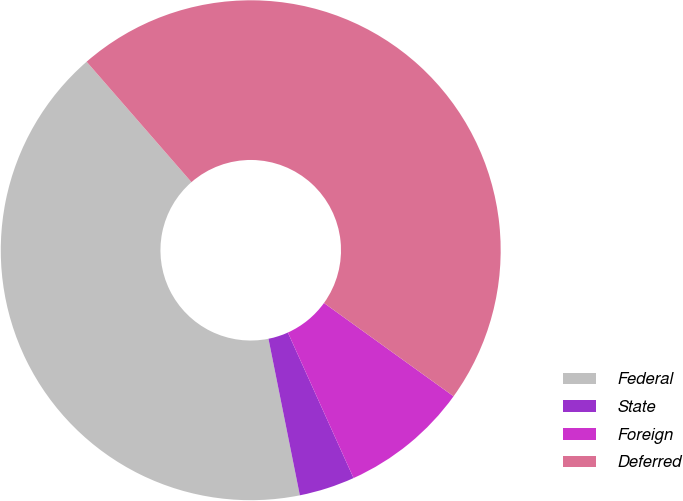<chart> <loc_0><loc_0><loc_500><loc_500><pie_chart><fcel>Federal<fcel>State<fcel>Foreign<fcel>Deferred<nl><fcel>41.75%<fcel>3.6%<fcel>8.32%<fcel>46.33%<nl></chart> 